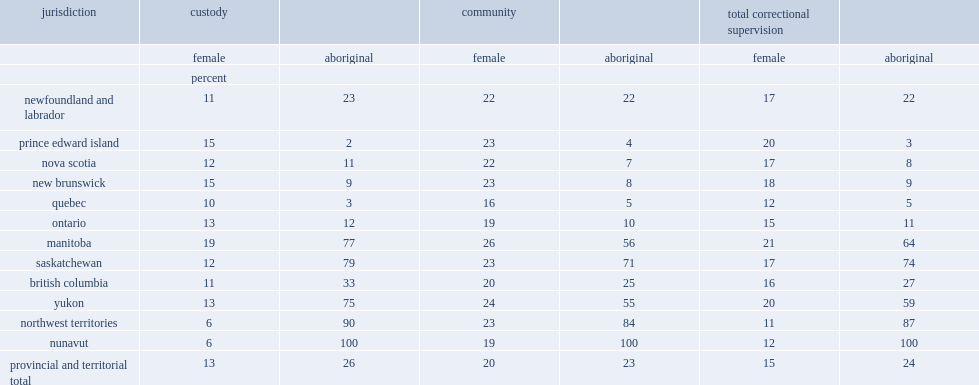While accounting for 15% of overall admissions, which sector has smaller share of female admissions? custody or community supervision? Custody. How many percent of admissions to total correctional supervision in 2013/2014 are aboriginal adults? 24.0. How many percent of total custodial admissions in the provinces and territories in 2013/2014 are admitted by aboriginal people? 26.0. How many percent of total community admissions are addmited by aboriginal people in the provinces and territories? 23.0. 